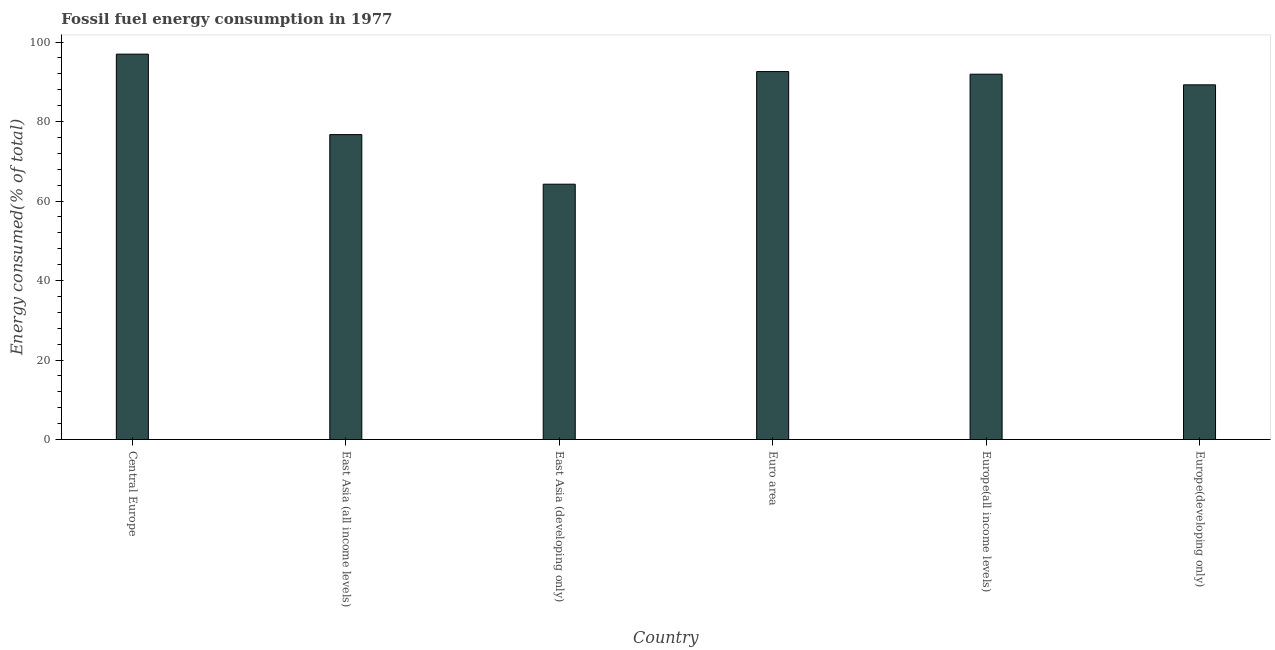Does the graph contain any zero values?
Give a very brief answer. No. What is the title of the graph?
Give a very brief answer. Fossil fuel energy consumption in 1977. What is the label or title of the X-axis?
Provide a succinct answer. Country. What is the label or title of the Y-axis?
Provide a succinct answer. Energy consumed(% of total). What is the fossil fuel energy consumption in Europe(all income levels)?
Provide a short and direct response. 91.9. Across all countries, what is the maximum fossil fuel energy consumption?
Your response must be concise. 96.95. Across all countries, what is the minimum fossil fuel energy consumption?
Offer a very short reply. 64.23. In which country was the fossil fuel energy consumption maximum?
Provide a short and direct response. Central Europe. In which country was the fossil fuel energy consumption minimum?
Offer a terse response. East Asia (developing only). What is the sum of the fossil fuel energy consumption?
Your answer should be compact. 511.58. What is the difference between the fossil fuel energy consumption in East Asia (developing only) and Euro area?
Give a very brief answer. -28.33. What is the average fossil fuel energy consumption per country?
Provide a succinct answer. 85.26. What is the median fossil fuel energy consumption?
Ensure brevity in your answer.  90.56. What is the ratio of the fossil fuel energy consumption in East Asia (all income levels) to that in Europe(all income levels)?
Your answer should be very brief. 0.83. Is the difference between the fossil fuel energy consumption in East Asia (all income levels) and East Asia (developing only) greater than the difference between any two countries?
Make the answer very short. No. What is the difference between the highest and the second highest fossil fuel energy consumption?
Your response must be concise. 4.38. Is the sum of the fossil fuel energy consumption in East Asia (developing only) and Europe(developing only) greater than the maximum fossil fuel energy consumption across all countries?
Give a very brief answer. Yes. What is the difference between the highest and the lowest fossil fuel energy consumption?
Ensure brevity in your answer.  32.72. In how many countries, is the fossil fuel energy consumption greater than the average fossil fuel energy consumption taken over all countries?
Provide a short and direct response. 4. How many bars are there?
Offer a very short reply. 6. What is the difference between two consecutive major ticks on the Y-axis?
Provide a short and direct response. 20. Are the values on the major ticks of Y-axis written in scientific E-notation?
Provide a succinct answer. No. What is the Energy consumed(% of total) in Central Europe?
Your answer should be compact. 96.95. What is the Energy consumed(% of total) in East Asia (all income levels)?
Your answer should be very brief. 76.7. What is the Energy consumed(% of total) of East Asia (developing only)?
Provide a succinct answer. 64.23. What is the Energy consumed(% of total) of Euro area?
Your response must be concise. 92.57. What is the Energy consumed(% of total) of Europe(all income levels)?
Provide a succinct answer. 91.9. What is the Energy consumed(% of total) of Europe(developing only)?
Provide a short and direct response. 89.23. What is the difference between the Energy consumed(% of total) in Central Europe and East Asia (all income levels)?
Give a very brief answer. 20.25. What is the difference between the Energy consumed(% of total) in Central Europe and East Asia (developing only)?
Keep it short and to the point. 32.72. What is the difference between the Energy consumed(% of total) in Central Europe and Euro area?
Your answer should be very brief. 4.38. What is the difference between the Energy consumed(% of total) in Central Europe and Europe(all income levels)?
Provide a succinct answer. 5.05. What is the difference between the Energy consumed(% of total) in Central Europe and Europe(developing only)?
Your answer should be very brief. 7.72. What is the difference between the Energy consumed(% of total) in East Asia (all income levels) and East Asia (developing only)?
Ensure brevity in your answer.  12.47. What is the difference between the Energy consumed(% of total) in East Asia (all income levels) and Euro area?
Your answer should be very brief. -15.86. What is the difference between the Energy consumed(% of total) in East Asia (all income levels) and Europe(all income levels)?
Give a very brief answer. -15.2. What is the difference between the Energy consumed(% of total) in East Asia (all income levels) and Europe(developing only)?
Your response must be concise. -12.52. What is the difference between the Energy consumed(% of total) in East Asia (developing only) and Euro area?
Provide a succinct answer. -28.33. What is the difference between the Energy consumed(% of total) in East Asia (developing only) and Europe(all income levels)?
Your response must be concise. -27.67. What is the difference between the Energy consumed(% of total) in East Asia (developing only) and Europe(developing only)?
Make the answer very short. -24.99. What is the difference between the Energy consumed(% of total) in Euro area and Europe(all income levels)?
Offer a very short reply. 0.66. What is the difference between the Energy consumed(% of total) in Euro area and Europe(developing only)?
Keep it short and to the point. 3.34. What is the difference between the Energy consumed(% of total) in Europe(all income levels) and Europe(developing only)?
Provide a succinct answer. 2.68. What is the ratio of the Energy consumed(% of total) in Central Europe to that in East Asia (all income levels)?
Your answer should be very brief. 1.26. What is the ratio of the Energy consumed(% of total) in Central Europe to that in East Asia (developing only)?
Your response must be concise. 1.51. What is the ratio of the Energy consumed(% of total) in Central Europe to that in Euro area?
Your answer should be very brief. 1.05. What is the ratio of the Energy consumed(% of total) in Central Europe to that in Europe(all income levels)?
Keep it short and to the point. 1.05. What is the ratio of the Energy consumed(% of total) in Central Europe to that in Europe(developing only)?
Give a very brief answer. 1.09. What is the ratio of the Energy consumed(% of total) in East Asia (all income levels) to that in East Asia (developing only)?
Offer a terse response. 1.19. What is the ratio of the Energy consumed(% of total) in East Asia (all income levels) to that in Euro area?
Offer a very short reply. 0.83. What is the ratio of the Energy consumed(% of total) in East Asia (all income levels) to that in Europe(all income levels)?
Your answer should be compact. 0.83. What is the ratio of the Energy consumed(% of total) in East Asia (all income levels) to that in Europe(developing only)?
Keep it short and to the point. 0.86. What is the ratio of the Energy consumed(% of total) in East Asia (developing only) to that in Euro area?
Make the answer very short. 0.69. What is the ratio of the Energy consumed(% of total) in East Asia (developing only) to that in Europe(all income levels)?
Your answer should be compact. 0.7. What is the ratio of the Energy consumed(% of total) in East Asia (developing only) to that in Europe(developing only)?
Offer a terse response. 0.72. What is the ratio of the Energy consumed(% of total) in Euro area to that in Europe(all income levels)?
Offer a terse response. 1.01. What is the ratio of the Energy consumed(% of total) in Europe(all income levels) to that in Europe(developing only)?
Your answer should be very brief. 1.03. 